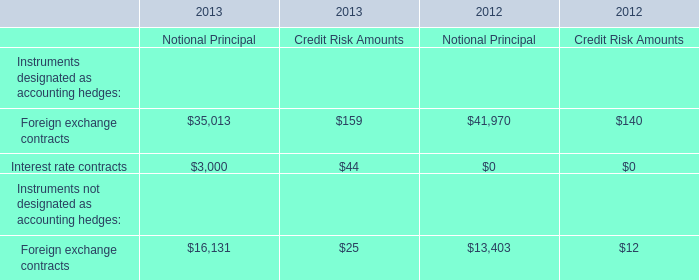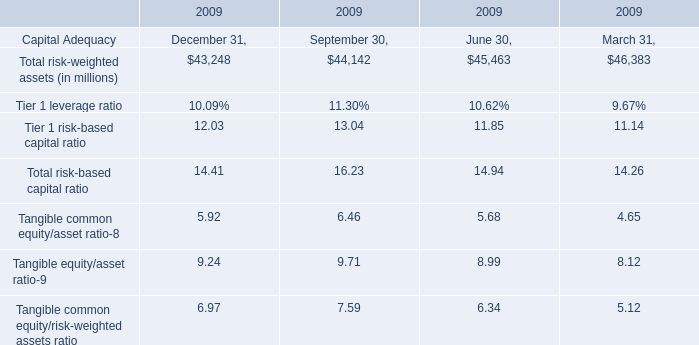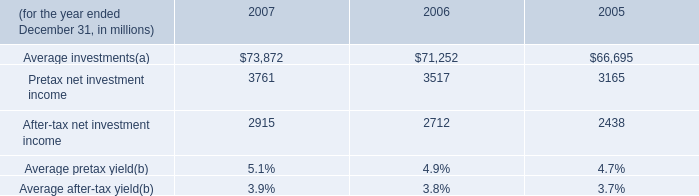What is the highest Total risk-weighted assets between December 31,September 30,June 30,March 31 in 2009? (in million) 
Answer: 46383. 